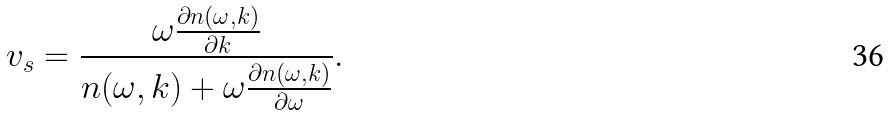Convert formula to latex. <formula><loc_0><loc_0><loc_500><loc_500>v _ { s } = \frac { \omega \frac { \partial n ( \omega , k ) } { \partial k } } { n ( \omega , k ) + \omega \frac { \partial n ( \omega , k ) } { \partial \omega } } .</formula> 